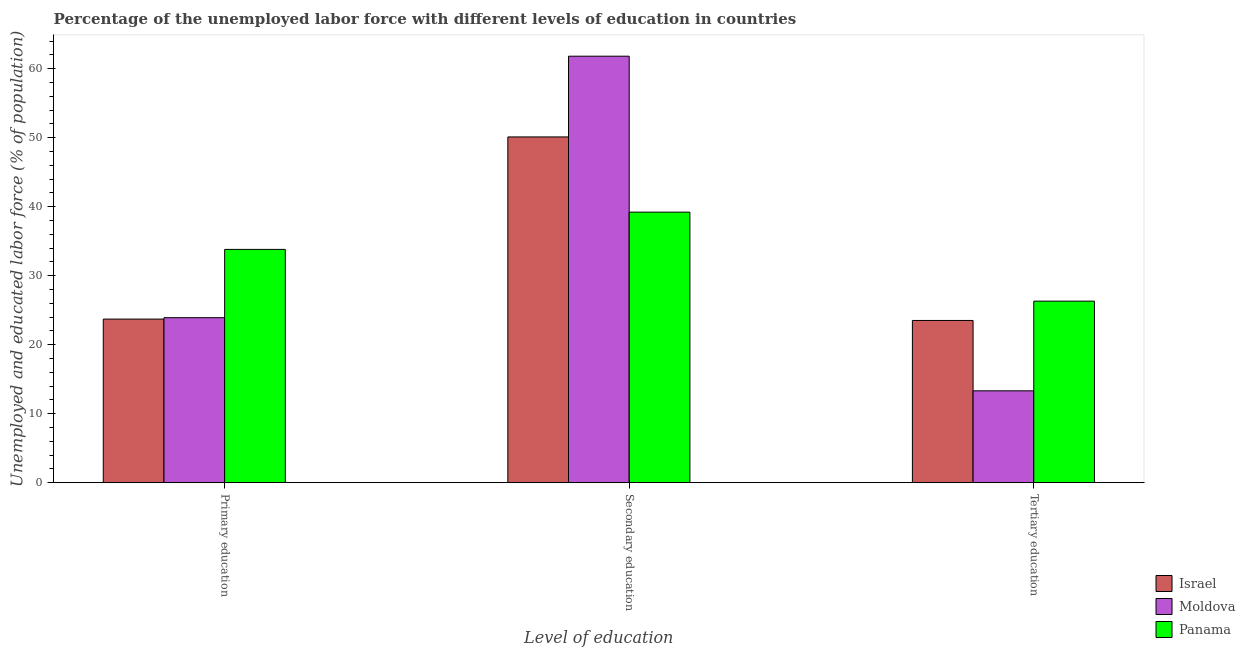Are the number of bars per tick equal to the number of legend labels?
Your answer should be very brief. Yes. How many bars are there on the 2nd tick from the left?
Give a very brief answer. 3. What is the label of the 3rd group of bars from the left?
Make the answer very short. Tertiary education. What is the percentage of labor force who received tertiary education in Moldova?
Offer a terse response. 13.3. Across all countries, what is the maximum percentage of labor force who received primary education?
Ensure brevity in your answer.  33.8. Across all countries, what is the minimum percentage of labor force who received secondary education?
Keep it short and to the point. 39.2. In which country was the percentage of labor force who received secondary education maximum?
Make the answer very short. Moldova. In which country was the percentage of labor force who received secondary education minimum?
Your response must be concise. Panama. What is the total percentage of labor force who received tertiary education in the graph?
Offer a terse response. 63.1. What is the difference between the percentage of labor force who received primary education in Israel and that in Moldova?
Your answer should be very brief. -0.2. What is the difference between the percentage of labor force who received secondary education in Panama and the percentage of labor force who received tertiary education in Israel?
Make the answer very short. 15.7. What is the average percentage of labor force who received tertiary education per country?
Provide a succinct answer. 21.03. What is the difference between the percentage of labor force who received tertiary education and percentage of labor force who received primary education in Moldova?
Your answer should be compact. -10.6. In how many countries, is the percentage of labor force who received tertiary education greater than 58 %?
Your answer should be compact. 0. What is the ratio of the percentage of labor force who received secondary education in Israel to that in Moldova?
Ensure brevity in your answer.  0.81. Is the percentage of labor force who received tertiary education in Panama less than that in Israel?
Your answer should be compact. No. Is the difference between the percentage of labor force who received primary education in Israel and Panama greater than the difference between the percentage of labor force who received secondary education in Israel and Panama?
Make the answer very short. No. What is the difference between the highest and the second highest percentage of labor force who received secondary education?
Provide a short and direct response. 11.7. What is the difference between the highest and the lowest percentage of labor force who received secondary education?
Keep it short and to the point. 22.6. In how many countries, is the percentage of labor force who received secondary education greater than the average percentage of labor force who received secondary education taken over all countries?
Your response must be concise. 1. What does the 3rd bar from the left in Primary education represents?
Your response must be concise. Panama. What does the 1st bar from the right in Tertiary education represents?
Provide a succinct answer. Panama. Are all the bars in the graph horizontal?
Offer a terse response. No. Does the graph contain any zero values?
Give a very brief answer. No. Does the graph contain grids?
Ensure brevity in your answer.  No. Where does the legend appear in the graph?
Provide a short and direct response. Bottom right. How many legend labels are there?
Your answer should be very brief. 3. What is the title of the graph?
Make the answer very short. Percentage of the unemployed labor force with different levels of education in countries. What is the label or title of the X-axis?
Offer a terse response. Level of education. What is the label or title of the Y-axis?
Your answer should be very brief. Unemployed and educated labor force (% of population). What is the Unemployed and educated labor force (% of population) of Israel in Primary education?
Make the answer very short. 23.7. What is the Unemployed and educated labor force (% of population) in Moldova in Primary education?
Provide a succinct answer. 23.9. What is the Unemployed and educated labor force (% of population) in Panama in Primary education?
Make the answer very short. 33.8. What is the Unemployed and educated labor force (% of population) of Israel in Secondary education?
Give a very brief answer. 50.1. What is the Unemployed and educated labor force (% of population) of Moldova in Secondary education?
Provide a short and direct response. 61.8. What is the Unemployed and educated labor force (% of population) of Panama in Secondary education?
Provide a short and direct response. 39.2. What is the Unemployed and educated labor force (% of population) of Israel in Tertiary education?
Make the answer very short. 23.5. What is the Unemployed and educated labor force (% of population) of Moldova in Tertiary education?
Provide a succinct answer. 13.3. What is the Unemployed and educated labor force (% of population) of Panama in Tertiary education?
Your answer should be very brief. 26.3. Across all Level of education, what is the maximum Unemployed and educated labor force (% of population) of Israel?
Make the answer very short. 50.1. Across all Level of education, what is the maximum Unemployed and educated labor force (% of population) in Moldova?
Make the answer very short. 61.8. Across all Level of education, what is the maximum Unemployed and educated labor force (% of population) in Panama?
Make the answer very short. 39.2. Across all Level of education, what is the minimum Unemployed and educated labor force (% of population) of Israel?
Offer a very short reply. 23.5. Across all Level of education, what is the minimum Unemployed and educated labor force (% of population) in Moldova?
Give a very brief answer. 13.3. Across all Level of education, what is the minimum Unemployed and educated labor force (% of population) in Panama?
Provide a succinct answer. 26.3. What is the total Unemployed and educated labor force (% of population) of Israel in the graph?
Your response must be concise. 97.3. What is the total Unemployed and educated labor force (% of population) of Moldova in the graph?
Offer a terse response. 99. What is the total Unemployed and educated labor force (% of population) in Panama in the graph?
Make the answer very short. 99.3. What is the difference between the Unemployed and educated labor force (% of population) of Israel in Primary education and that in Secondary education?
Offer a terse response. -26.4. What is the difference between the Unemployed and educated labor force (% of population) of Moldova in Primary education and that in Secondary education?
Your answer should be very brief. -37.9. What is the difference between the Unemployed and educated labor force (% of population) in Panama in Primary education and that in Secondary education?
Ensure brevity in your answer.  -5.4. What is the difference between the Unemployed and educated labor force (% of population) in Israel in Primary education and that in Tertiary education?
Your answer should be very brief. 0.2. What is the difference between the Unemployed and educated labor force (% of population) in Panama in Primary education and that in Tertiary education?
Provide a short and direct response. 7.5. What is the difference between the Unemployed and educated labor force (% of population) of Israel in Secondary education and that in Tertiary education?
Give a very brief answer. 26.6. What is the difference between the Unemployed and educated labor force (% of population) of Moldova in Secondary education and that in Tertiary education?
Your answer should be compact. 48.5. What is the difference between the Unemployed and educated labor force (% of population) of Panama in Secondary education and that in Tertiary education?
Your response must be concise. 12.9. What is the difference between the Unemployed and educated labor force (% of population) of Israel in Primary education and the Unemployed and educated labor force (% of population) of Moldova in Secondary education?
Offer a terse response. -38.1. What is the difference between the Unemployed and educated labor force (% of population) of Israel in Primary education and the Unemployed and educated labor force (% of population) of Panama in Secondary education?
Offer a very short reply. -15.5. What is the difference between the Unemployed and educated labor force (% of population) of Moldova in Primary education and the Unemployed and educated labor force (% of population) of Panama in Secondary education?
Provide a succinct answer. -15.3. What is the difference between the Unemployed and educated labor force (% of population) in Israel in Primary education and the Unemployed and educated labor force (% of population) in Moldova in Tertiary education?
Provide a succinct answer. 10.4. What is the difference between the Unemployed and educated labor force (% of population) in Israel in Secondary education and the Unemployed and educated labor force (% of population) in Moldova in Tertiary education?
Your response must be concise. 36.8. What is the difference between the Unemployed and educated labor force (% of population) in Israel in Secondary education and the Unemployed and educated labor force (% of population) in Panama in Tertiary education?
Keep it short and to the point. 23.8. What is the difference between the Unemployed and educated labor force (% of population) of Moldova in Secondary education and the Unemployed and educated labor force (% of population) of Panama in Tertiary education?
Provide a short and direct response. 35.5. What is the average Unemployed and educated labor force (% of population) of Israel per Level of education?
Give a very brief answer. 32.43. What is the average Unemployed and educated labor force (% of population) of Moldova per Level of education?
Your answer should be compact. 33. What is the average Unemployed and educated labor force (% of population) in Panama per Level of education?
Ensure brevity in your answer.  33.1. What is the difference between the Unemployed and educated labor force (% of population) in Israel and Unemployed and educated labor force (% of population) in Moldova in Primary education?
Offer a very short reply. -0.2. What is the difference between the Unemployed and educated labor force (% of population) of Israel and Unemployed and educated labor force (% of population) of Panama in Primary education?
Your answer should be compact. -10.1. What is the difference between the Unemployed and educated labor force (% of population) in Moldova and Unemployed and educated labor force (% of population) in Panama in Primary education?
Keep it short and to the point. -9.9. What is the difference between the Unemployed and educated labor force (% of population) in Israel and Unemployed and educated labor force (% of population) in Moldova in Secondary education?
Offer a terse response. -11.7. What is the difference between the Unemployed and educated labor force (% of population) of Moldova and Unemployed and educated labor force (% of population) of Panama in Secondary education?
Provide a short and direct response. 22.6. What is the difference between the Unemployed and educated labor force (% of population) in Israel and Unemployed and educated labor force (% of population) in Moldova in Tertiary education?
Keep it short and to the point. 10.2. What is the difference between the Unemployed and educated labor force (% of population) in Moldova and Unemployed and educated labor force (% of population) in Panama in Tertiary education?
Give a very brief answer. -13. What is the ratio of the Unemployed and educated labor force (% of population) of Israel in Primary education to that in Secondary education?
Offer a very short reply. 0.47. What is the ratio of the Unemployed and educated labor force (% of population) of Moldova in Primary education to that in Secondary education?
Give a very brief answer. 0.39. What is the ratio of the Unemployed and educated labor force (% of population) of Panama in Primary education to that in Secondary education?
Keep it short and to the point. 0.86. What is the ratio of the Unemployed and educated labor force (% of population) in Israel in Primary education to that in Tertiary education?
Make the answer very short. 1.01. What is the ratio of the Unemployed and educated labor force (% of population) in Moldova in Primary education to that in Tertiary education?
Provide a short and direct response. 1.8. What is the ratio of the Unemployed and educated labor force (% of population) of Panama in Primary education to that in Tertiary education?
Offer a terse response. 1.29. What is the ratio of the Unemployed and educated labor force (% of population) of Israel in Secondary education to that in Tertiary education?
Make the answer very short. 2.13. What is the ratio of the Unemployed and educated labor force (% of population) in Moldova in Secondary education to that in Tertiary education?
Give a very brief answer. 4.65. What is the ratio of the Unemployed and educated labor force (% of population) of Panama in Secondary education to that in Tertiary education?
Keep it short and to the point. 1.49. What is the difference between the highest and the second highest Unemployed and educated labor force (% of population) in Israel?
Offer a very short reply. 26.4. What is the difference between the highest and the second highest Unemployed and educated labor force (% of population) in Moldova?
Provide a short and direct response. 37.9. What is the difference between the highest and the second highest Unemployed and educated labor force (% of population) of Panama?
Offer a terse response. 5.4. What is the difference between the highest and the lowest Unemployed and educated labor force (% of population) of Israel?
Ensure brevity in your answer.  26.6. What is the difference between the highest and the lowest Unemployed and educated labor force (% of population) in Moldova?
Your response must be concise. 48.5. What is the difference between the highest and the lowest Unemployed and educated labor force (% of population) of Panama?
Your answer should be compact. 12.9. 